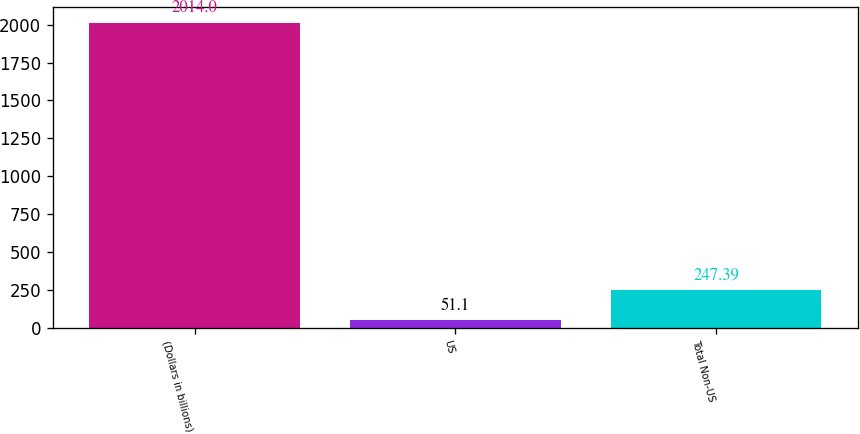Convert chart to OTSL. <chart><loc_0><loc_0><loc_500><loc_500><bar_chart><fcel>(Dollars in billions)<fcel>US<fcel>Total Non-US<nl><fcel>2014<fcel>51.1<fcel>247.39<nl></chart> 